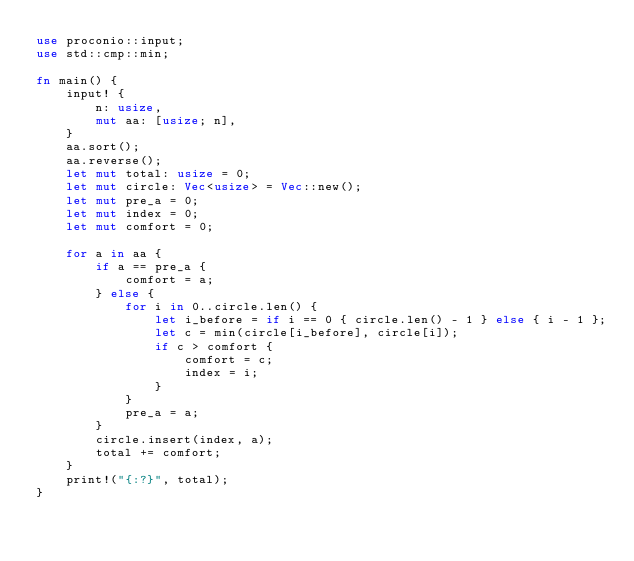<code> <loc_0><loc_0><loc_500><loc_500><_Rust_>use proconio::input;
use std::cmp::min;

fn main() {
    input! {
        n: usize,
        mut aa: [usize; n],
    }
    aa.sort();
    aa.reverse();
    let mut total: usize = 0;
    let mut circle: Vec<usize> = Vec::new();
    let mut pre_a = 0;
    let mut index = 0;
    let mut comfort = 0;

    for a in aa {
        if a == pre_a {
            comfort = a;
        } else {
            for i in 0..circle.len() {
                let i_before = if i == 0 { circle.len() - 1 } else { i - 1 };
                let c = min(circle[i_before], circle[i]);
                if c > comfort {
                    comfort = c;
                    index = i;
                }
            }
            pre_a = a;
        }
        circle.insert(index, a);
        total += comfort;
    }
    print!("{:?}", total);
}
</code> 